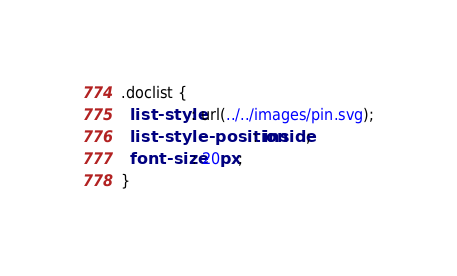Convert code to text. <code><loc_0><loc_0><loc_500><loc_500><_CSS_>.doclist {
  list-style: url(../../images/pin.svg);
  list-style-position: inside;
  font-size: 20px;
}
</code> 